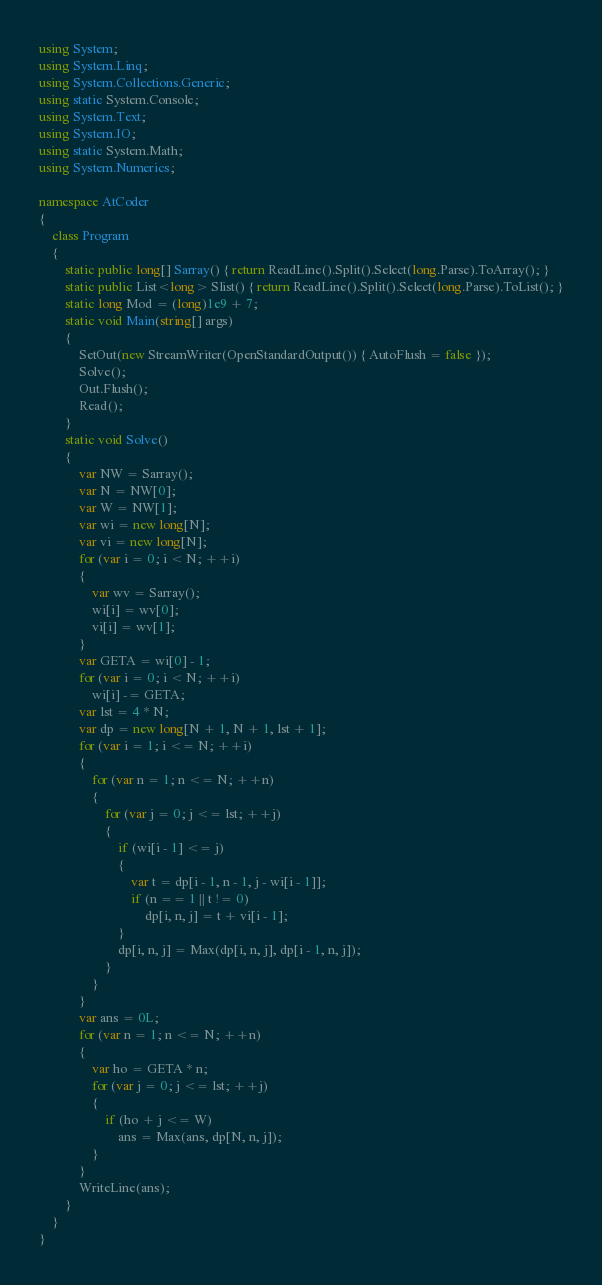Convert code to text. <code><loc_0><loc_0><loc_500><loc_500><_C#_>using System;
using System.Linq;
using System.Collections.Generic;
using static System.Console;
using System.Text;
using System.IO;
using static System.Math;
using System.Numerics;

namespace AtCoder
{
    class Program
    {
        static public long[] Sarray() { return ReadLine().Split().Select(long.Parse).ToArray(); }
        static public List<long> Slist() { return ReadLine().Split().Select(long.Parse).ToList(); }
        static long Mod = (long)1e9 + 7;
        static void Main(string[] args)
        {
            SetOut(new StreamWriter(OpenStandardOutput()) { AutoFlush = false });
            Solve();
            Out.Flush();
            Read();
        }
        static void Solve()
        {
            var NW = Sarray();
            var N = NW[0];
            var W = NW[1];
            var wi = new long[N];
            var vi = new long[N];
            for (var i = 0; i < N; ++i)
            {
                var wv = Sarray();
                wi[i] = wv[0];
                vi[i] = wv[1];
            }
            var GETA = wi[0] - 1;
            for (var i = 0; i < N; ++i)
                wi[i] -= GETA;
            var lst = 4 * N;
            var dp = new long[N + 1, N + 1, lst + 1];
            for (var i = 1; i <= N; ++i)
            {
                for (var n = 1; n <= N; ++n)
                {
                    for (var j = 0; j <= lst; ++j)
                    {
                        if (wi[i - 1] <= j)
                        {
                            var t = dp[i - 1, n - 1, j - wi[i - 1]];
                            if (n == 1 || t != 0)
                                dp[i, n, j] = t + vi[i - 1];
                        }
                        dp[i, n, j] = Max(dp[i, n, j], dp[i - 1, n, j]);
                    }
                }
            }
            var ans = 0L;
            for (var n = 1; n <= N; ++n)
            {
                var ho = GETA * n;
                for (var j = 0; j <= lst; ++j)
                {
                    if (ho + j <= W)
                        ans = Max(ans, dp[N, n, j]);
                }
            }
            WriteLine(ans);
        }
    }
}</code> 